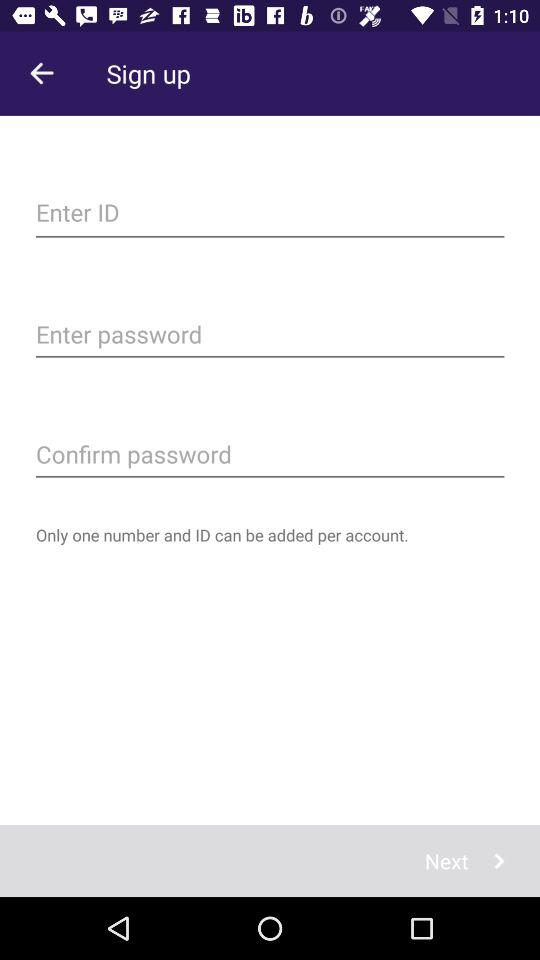How many numbers and IDs can be added to the account? There is only one number and ID that can be added per account. 